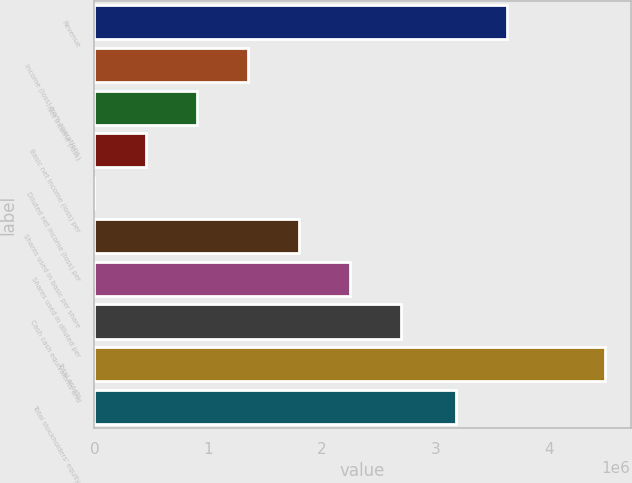<chart> <loc_0><loc_0><loc_500><loc_500><bar_chart><fcel>Revenue<fcel>Income (loss) from operations<fcel>Net income (loss)<fcel>Basic net income (loss) per<fcel>Diluted net income (loss) per<fcel>Shares used in basic per share<fcel>Shares used in diluted per<fcel>Cash cash equivalents and<fcel>Total assets<fcel>Total stockholders' equity<nl><fcel>3.63099e+06<fcel>1.34857e+06<fcel>899050<fcel>449525<fcel>0.43<fcel>1.7981e+06<fcel>2.24762e+06<fcel>2.69715e+06<fcel>4.49525e+06<fcel>3.18146e+06<nl></chart> 